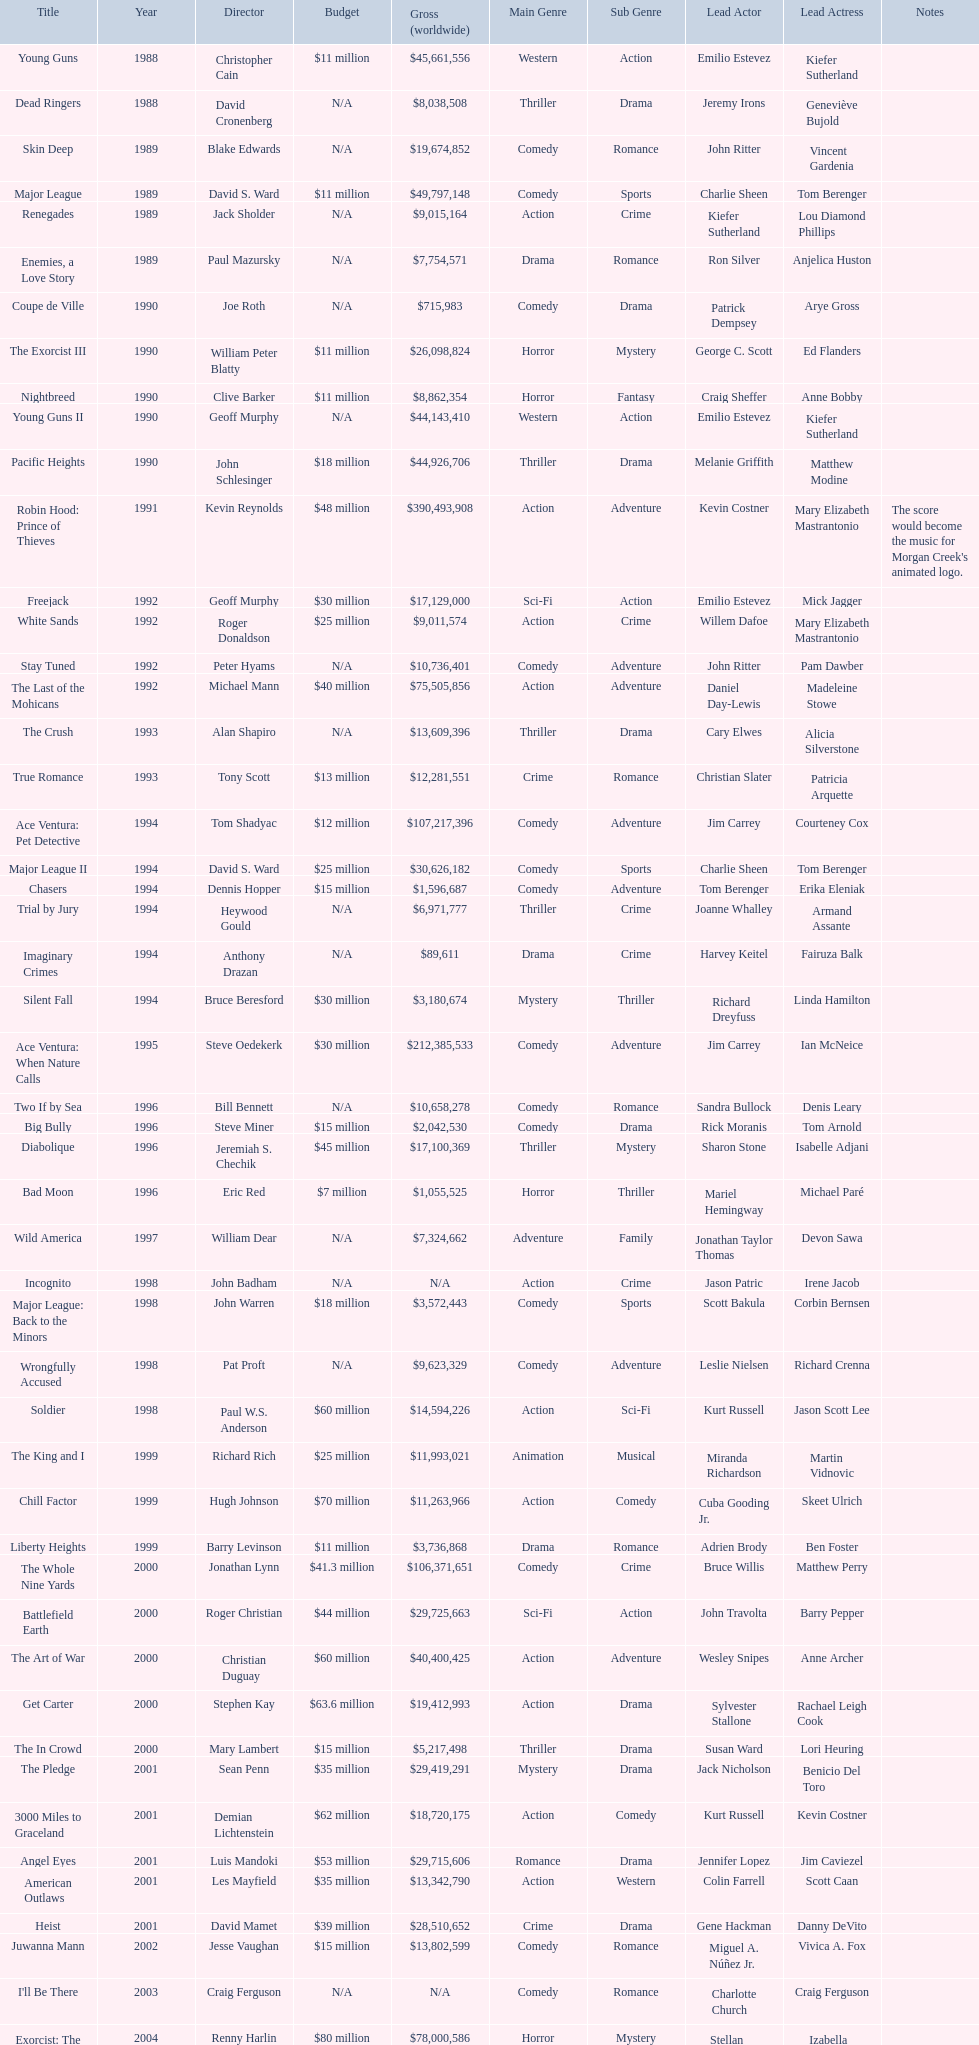Did true romance make more or less money than diabolique? Less. 